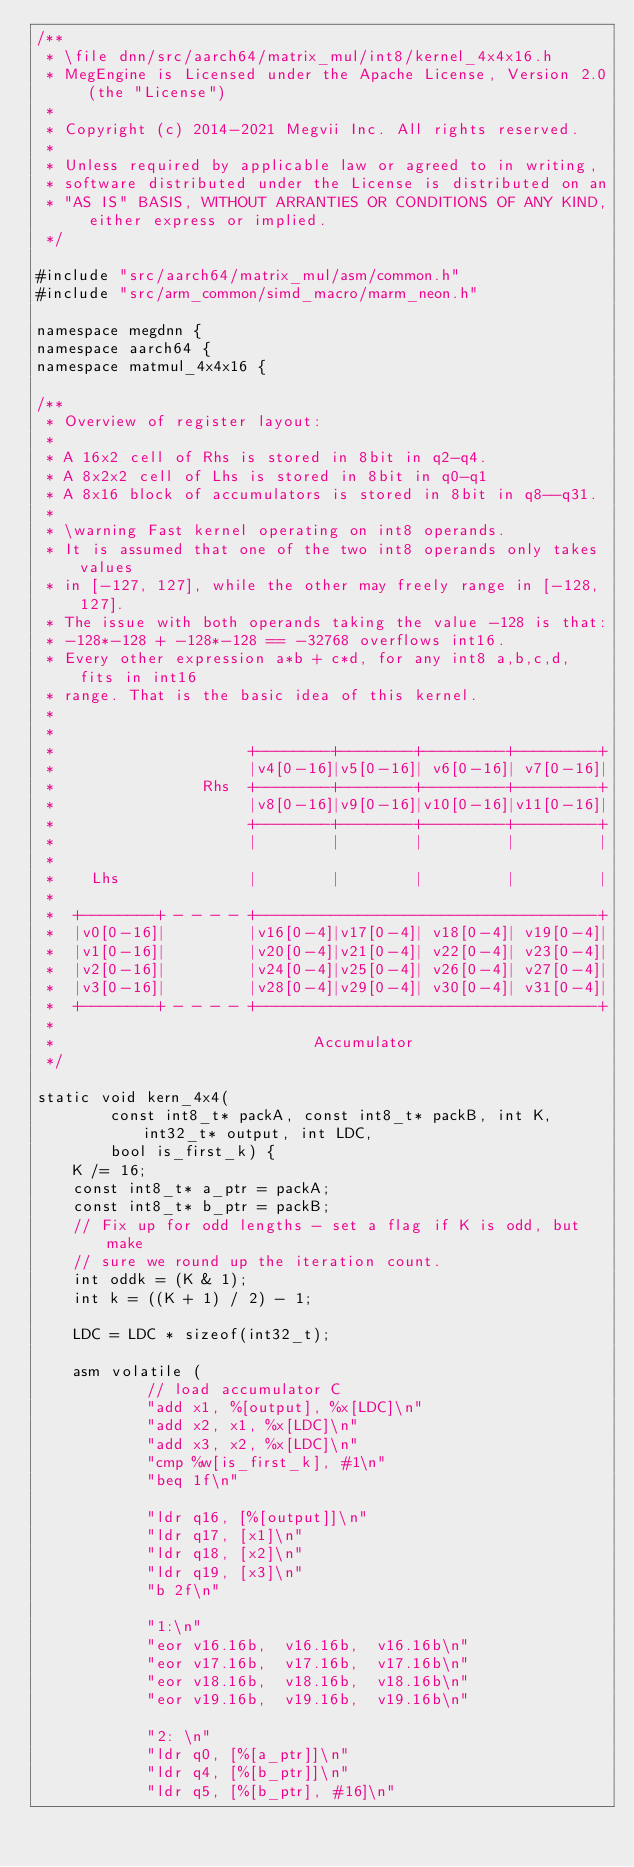<code> <loc_0><loc_0><loc_500><loc_500><_C_>/**
 * \file dnn/src/aarch64/matrix_mul/int8/kernel_4x4x16.h
 * MegEngine is Licensed under the Apache License, Version 2.0 (the "License")
 *
 * Copyright (c) 2014-2021 Megvii Inc. All rights reserved.
 *
 * Unless required by applicable law or agreed to in writing,
 * software distributed under the License is distributed on an
 * "AS IS" BASIS, WITHOUT ARRANTIES OR CONDITIONS OF ANY KIND, either express or implied.
 */

#include "src/aarch64/matrix_mul/asm/common.h"
#include "src/arm_common/simd_macro/marm_neon.h"

namespace megdnn {
namespace aarch64 {
namespace matmul_4x4x16 {

/**
 * Overview of register layout:
 *
 * A 16x2 cell of Rhs is stored in 8bit in q2-q4.
 * A 8x2x2 cell of Lhs is stored in 8bit in q0-q1
 * A 8x16 block of accumulators is stored in 8bit in q8--q31.
 *
 * \warning Fast kernel operating on int8 operands.
 * It is assumed that one of the two int8 operands only takes values
 * in [-127, 127], while the other may freely range in [-128, 127].
 * The issue with both operands taking the value -128 is that:
 * -128*-128 + -128*-128 == -32768 overflows int16.
 * Every other expression a*b + c*d, for any int8 a,b,c,d, fits in int16
 * range. That is the basic idea of this kernel.
 *
 *
 *                     +--------+--------+---------+---------+
 *                     |v4[0-16]|v5[0-16]| v6[0-16]| v7[0-16]|
 *                Rhs  +--------+--------+---------+---------+
 *                     |v8[0-16]|v9[0-16]|v10[0-16]|v11[0-16]|
 *                     +--------+--------+---------+---------+
 *                     |        |        |         |         |
 *
 *    Lhs              |        |        |         |         |
 *
 *  +--------+ - - - - +-------------------------------------+
 *  |v0[0-16]|         |v16[0-4]|v17[0-4]| v18[0-4]| v19[0-4]|
 *  |v1[0-16]|         |v20[0-4]|v21[0-4]| v22[0-4]| v23[0-4]|
 *  |v2[0-16]|         |v24[0-4]|v25[0-4]| v26[0-4]| v27[0-4]|
 *  |v3[0-16]|         |v28[0-4]|v29[0-4]| v30[0-4]| v31[0-4]|
 *  +--------+ - - - - +-------------------------------------+
 *
 *                            Accumulator
 */

static void kern_4x4(
        const int8_t* packA, const int8_t* packB, int K, int32_t* output, int LDC,
        bool is_first_k) {
    K /= 16;
    const int8_t* a_ptr = packA;
    const int8_t* b_ptr = packB;
    // Fix up for odd lengths - set a flag if K is odd, but make
    // sure we round up the iteration count.
    int oddk = (K & 1);
    int k = ((K + 1) / 2) - 1;

    LDC = LDC * sizeof(int32_t);

    asm volatile (
            // load accumulator C
            "add x1, %[output], %x[LDC]\n"
            "add x2, x1, %x[LDC]\n"
            "add x3, x2, %x[LDC]\n"
            "cmp %w[is_first_k], #1\n"
            "beq 1f\n"

            "ldr q16, [%[output]]\n"
            "ldr q17, [x1]\n"
            "ldr q18, [x2]\n"
            "ldr q19, [x3]\n"
            "b 2f\n"

            "1:\n"
            "eor v16.16b,  v16.16b,  v16.16b\n"
            "eor v17.16b,  v17.16b,  v17.16b\n"
            "eor v18.16b,  v18.16b,  v18.16b\n"
            "eor v19.16b,  v19.16b,  v19.16b\n"

            "2: \n"
            "ldr q0, [%[a_ptr]]\n"
            "ldr q4, [%[b_ptr]]\n"
            "ldr q5, [%[b_ptr], #16]\n"</code> 